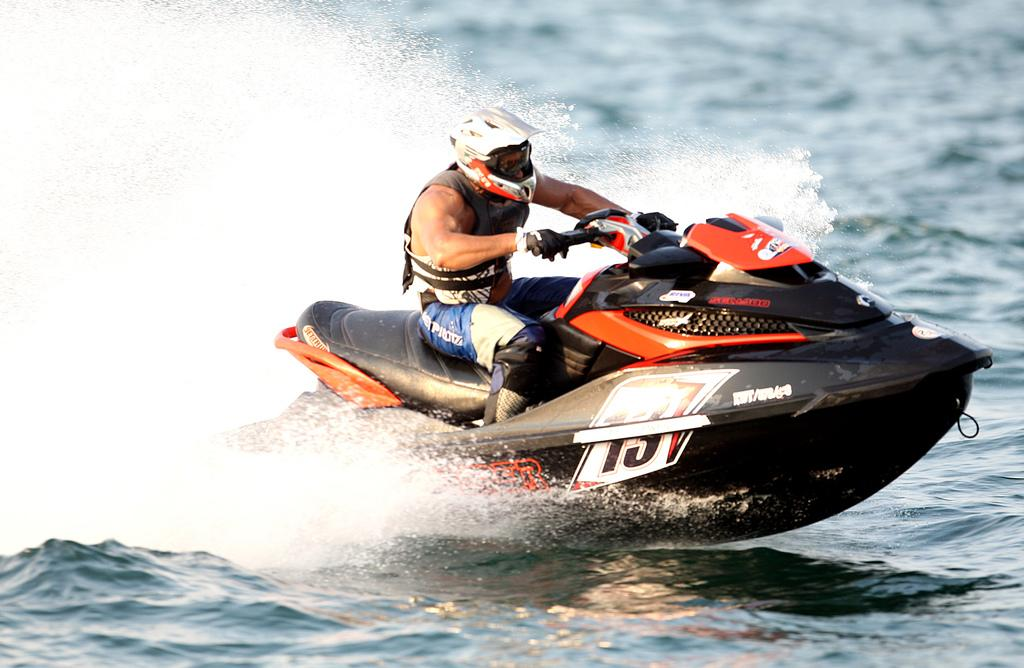What is the main subject of the image? The main subject of the image is a person riding a jet ski. What can be seen in the background of the image? There is a water body in the image. How many eggs are present in the image? There are no eggs visible in the image. What territory is being claimed by the person riding the jet ski in the image? The image does not depict any territorial claims or disputes; it simply shows a person riding a jet ski on a water body. 